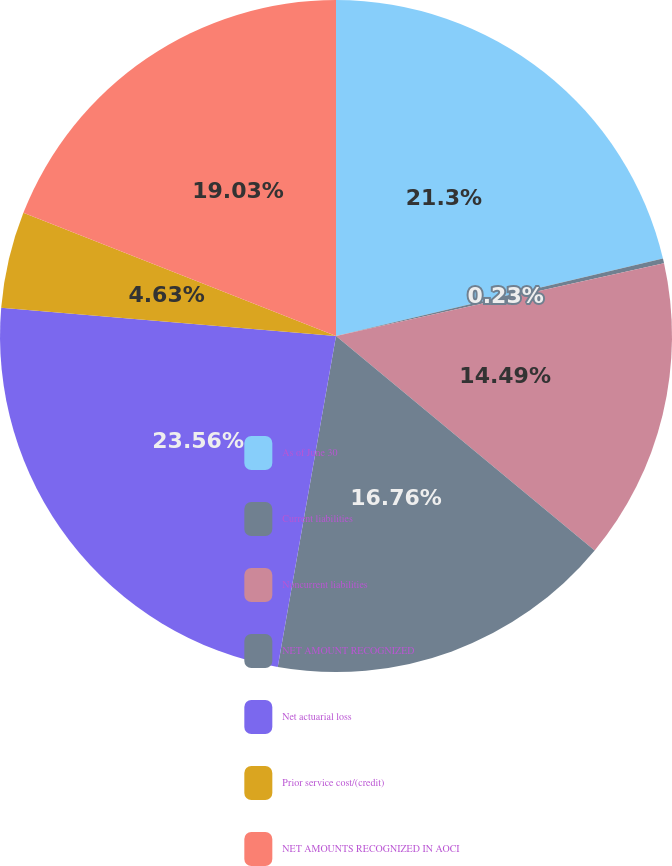Convert chart to OTSL. <chart><loc_0><loc_0><loc_500><loc_500><pie_chart><fcel>As of June 30<fcel>Current liabilities<fcel>Noncurrent liabilities<fcel>NET AMOUNT RECOGNIZED<fcel>Net actuarial loss<fcel>Prior service cost/(credit)<fcel>NET AMOUNTS RECOGNIZED IN AOCI<nl><fcel>21.3%<fcel>0.23%<fcel>14.49%<fcel>16.76%<fcel>23.57%<fcel>4.63%<fcel>19.03%<nl></chart> 